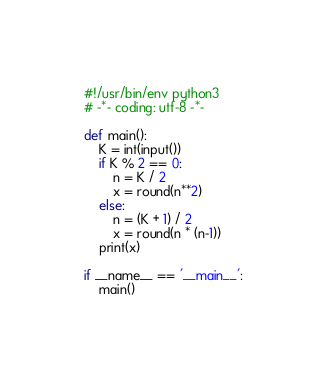<code> <loc_0><loc_0><loc_500><loc_500><_Python_>#!/usr/bin/env python3
# -*- coding: utf-8 -*-
 
def main():
	K = int(input())
	if K % 2 == 0:
		n = K / 2
		x = round(n**2)
	else:
		n = (K + 1) / 2
		x = round(n * (n-1))
	print(x)

if __name__ == '__main__':
	main()</code> 